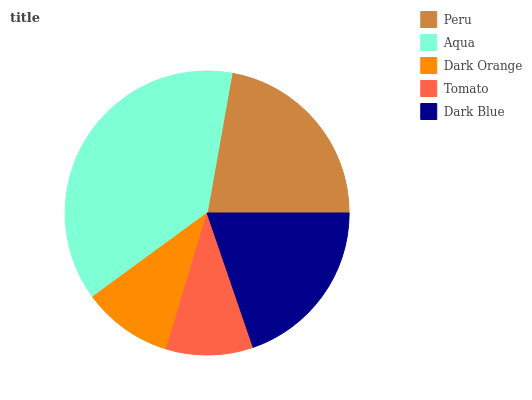Is Tomato the minimum?
Answer yes or no. Yes. Is Aqua the maximum?
Answer yes or no. Yes. Is Dark Orange the minimum?
Answer yes or no. No. Is Dark Orange the maximum?
Answer yes or no. No. Is Aqua greater than Dark Orange?
Answer yes or no. Yes. Is Dark Orange less than Aqua?
Answer yes or no. Yes. Is Dark Orange greater than Aqua?
Answer yes or no. No. Is Aqua less than Dark Orange?
Answer yes or no. No. Is Dark Blue the high median?
Answer yes or no. Yes. Is Dark Blue the low median?
Answer yes or no. Yes. Is Dark Orange the high median?
Answer yes or no. No. Is Dark Orange the low median?
Answer yes or no. No. 